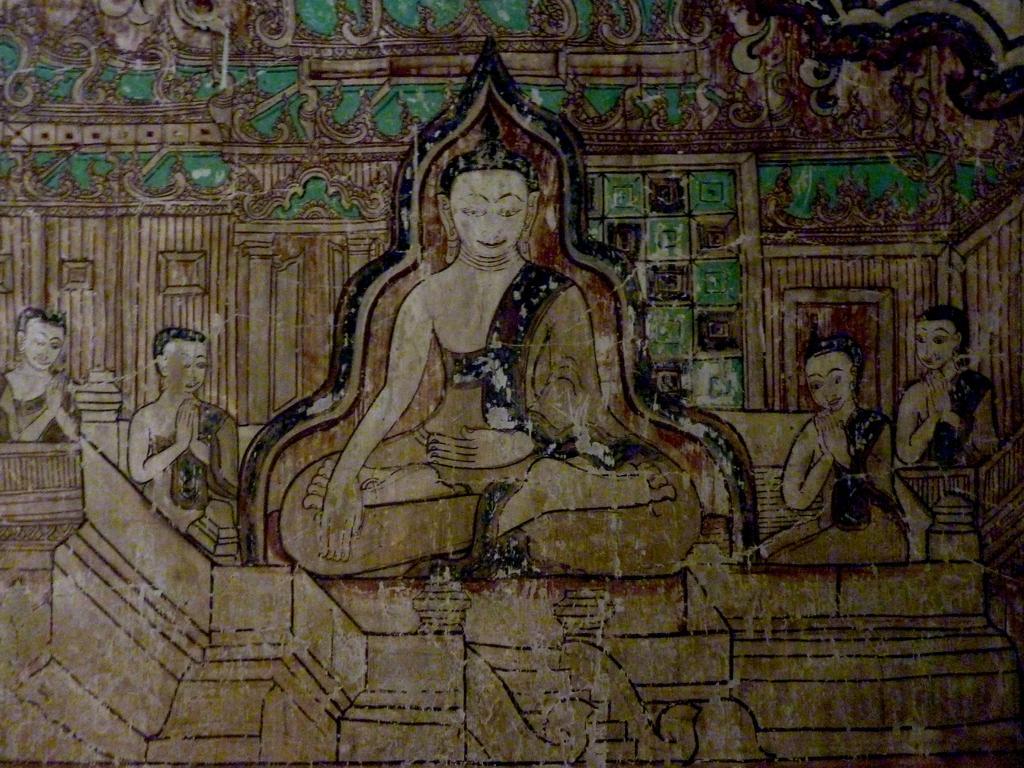Please provide a concise description of this image. In the center of the image we can see the painting, in which we can see a few people and some objects. 